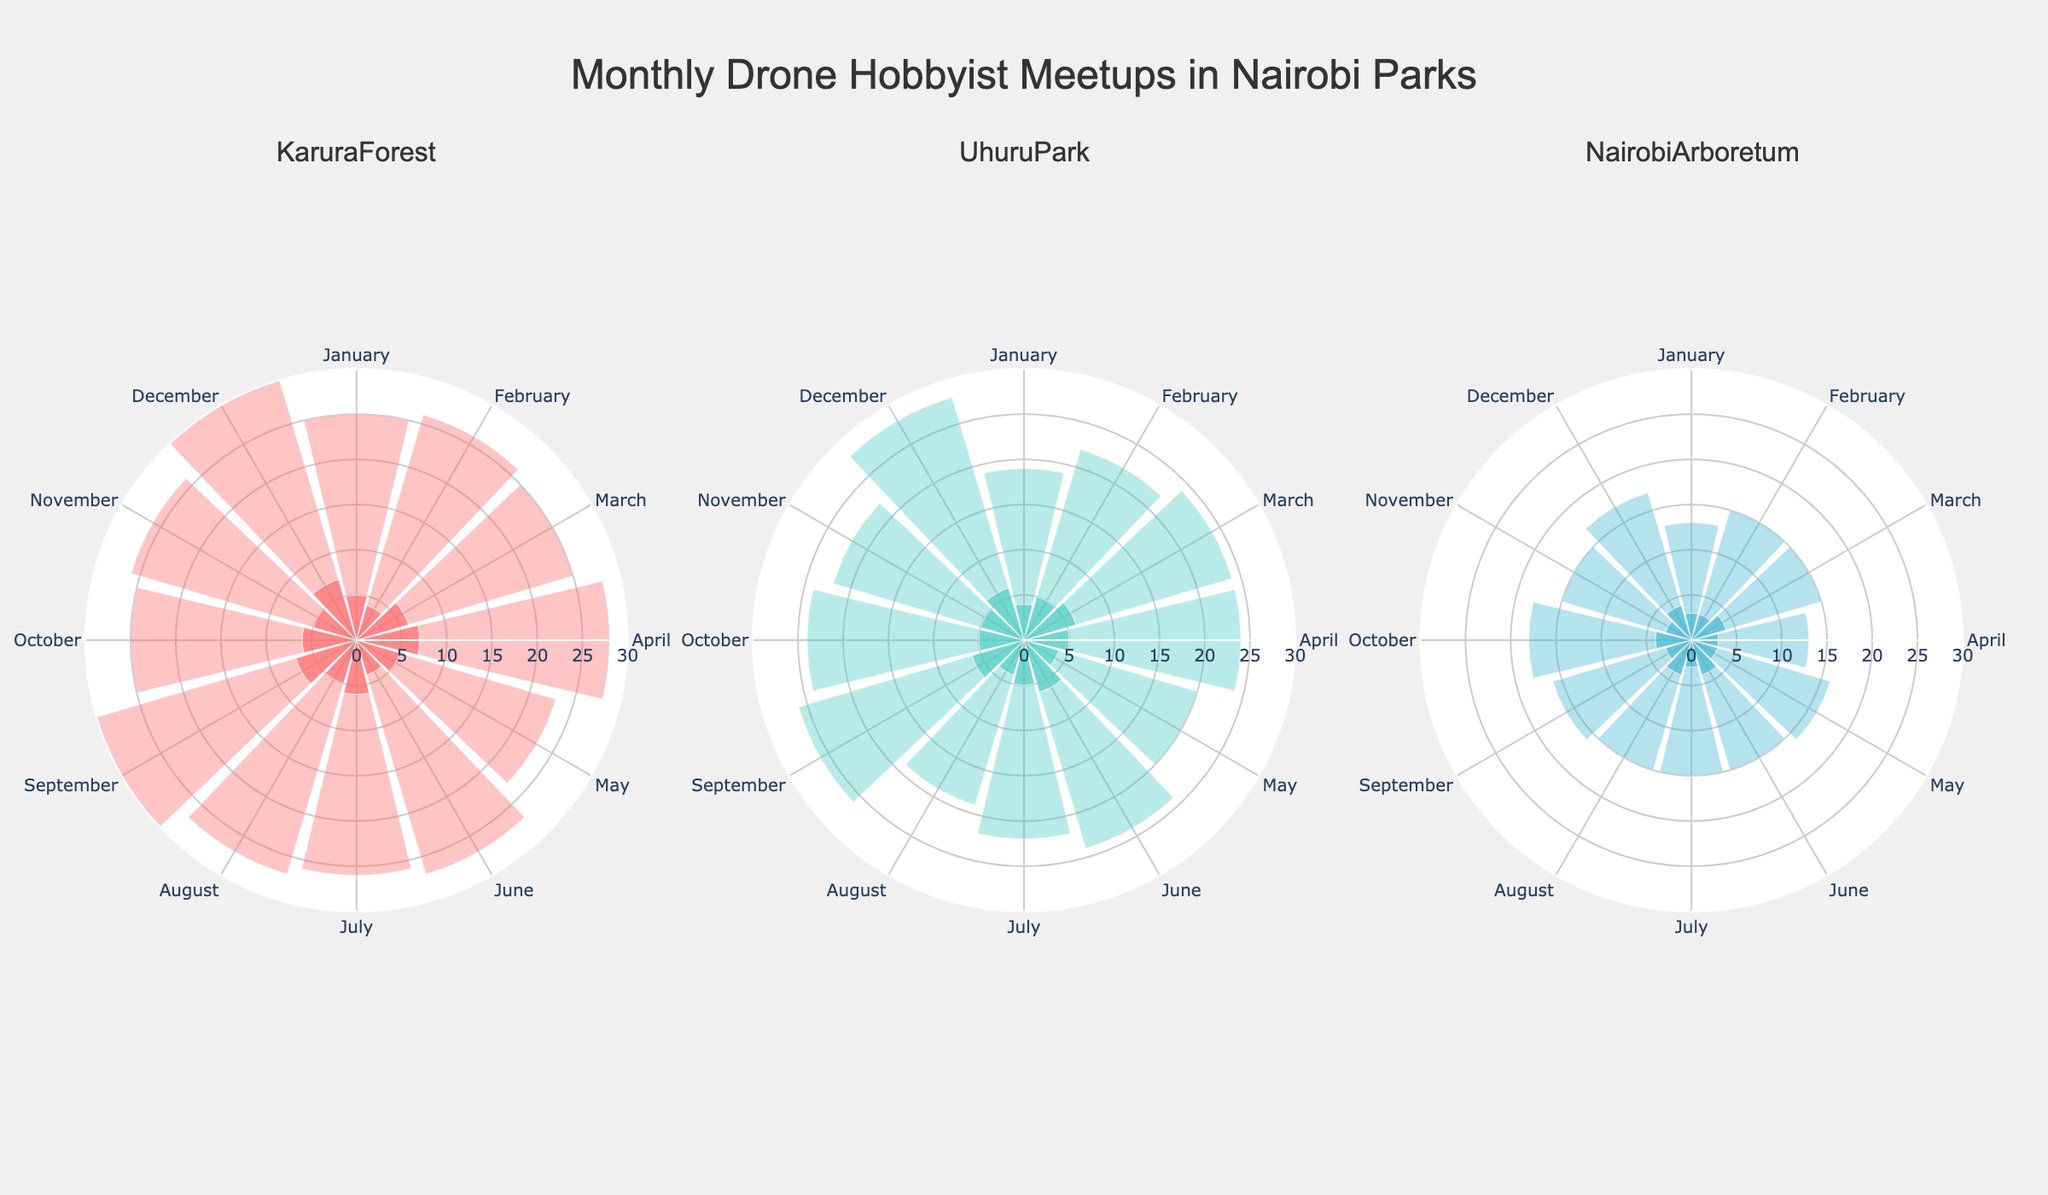Which park has the highest number of meetups in January? By looking at the “Number of Meetups” on the rose chart for January in each subplot, compare the data points. Karura Forest has 5 meetups, Uhuru Park has 4 meetups, and Nairobi Arboretum has 3 meetups.
Answer: Karura Forest What is the average attendance in Nairobi Arboretum in April? Locate the slice corresponding to April in the Nairobi Arboretum subplot that represents "Average Attendance." The value is 10 attendees.
Answer: 10 How many total meetups were there in Karura Forest in June and July? Sum the "Number of Meetups" for Karura Forest in June and July by looking at the respective slices in the plot. June has 4 and July has 6 meetups. So, 4 + 6 = 10.
Answer: 10 Which park has the highest average attendance in December? Check the data points for "Average Attendance" in December for each park. Karura Forest has 25, Uhuru Park has 22, and Nairobi Arboretum has 13. Karura Forest has the highest attendance.
Answer: Karura Forest Between Uhuru Park and Nairobi Arboretum, which one has more meetups in March? Compare the "Number of Meetups" in March for Uhuru Park and Nairobi Arboretum. Uhuru Park has 6, while Nairobi Arboretum has 4 meetups. Thus, Uhuru Park has more.
Answer: Uhuru Park What is the total number of meetups in all parks for November? Sum up the "Number of Meetups" in November for Karura Forest, Uhuru Park, and Nairobi Arboretum. Karura Forest: 5, Uhuru Park: 5, Nairobi Arboretum: 3. So, 5 + 5 + 3 = 13.
Answer: 13 Which month has the highest average attendance in Uhuru Park? Identify the month in Uhuru Park with the maximum value for "Average Attendance" by comparing the radial heights. The highest value is 22 in December.
Answer: December What is the difference in the number of meetups between Karura Forest and Nairobi Arboretum in February? Subtract the "Number of Meetups" in February for Nairobi Arboretum from that of Karura Forest. Karura Forest has 4, Nairobi Arboretum has 3. So, 4 - 3 = 1.
Answer: 1 Which park shows a consistent trend in the number of meetups across all months? Observe the overall spread and magnitude of the "Number of Meetups" for each park in their respective subplots. Nairobi Arboretum shows less variation and a more consistent trend with most meetups being around 3-4.
Answer: Nairobi Arboretum 